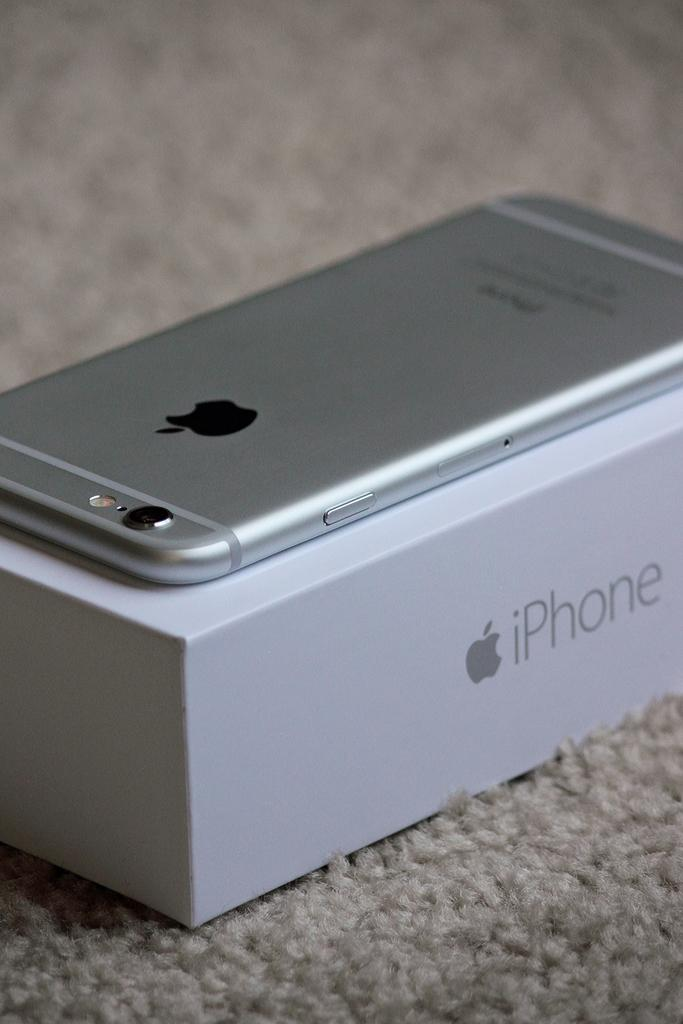<image>
Share a concise interpretation of the image provided. A phone with an apple on the back sitting on  top of a silver iphone box 